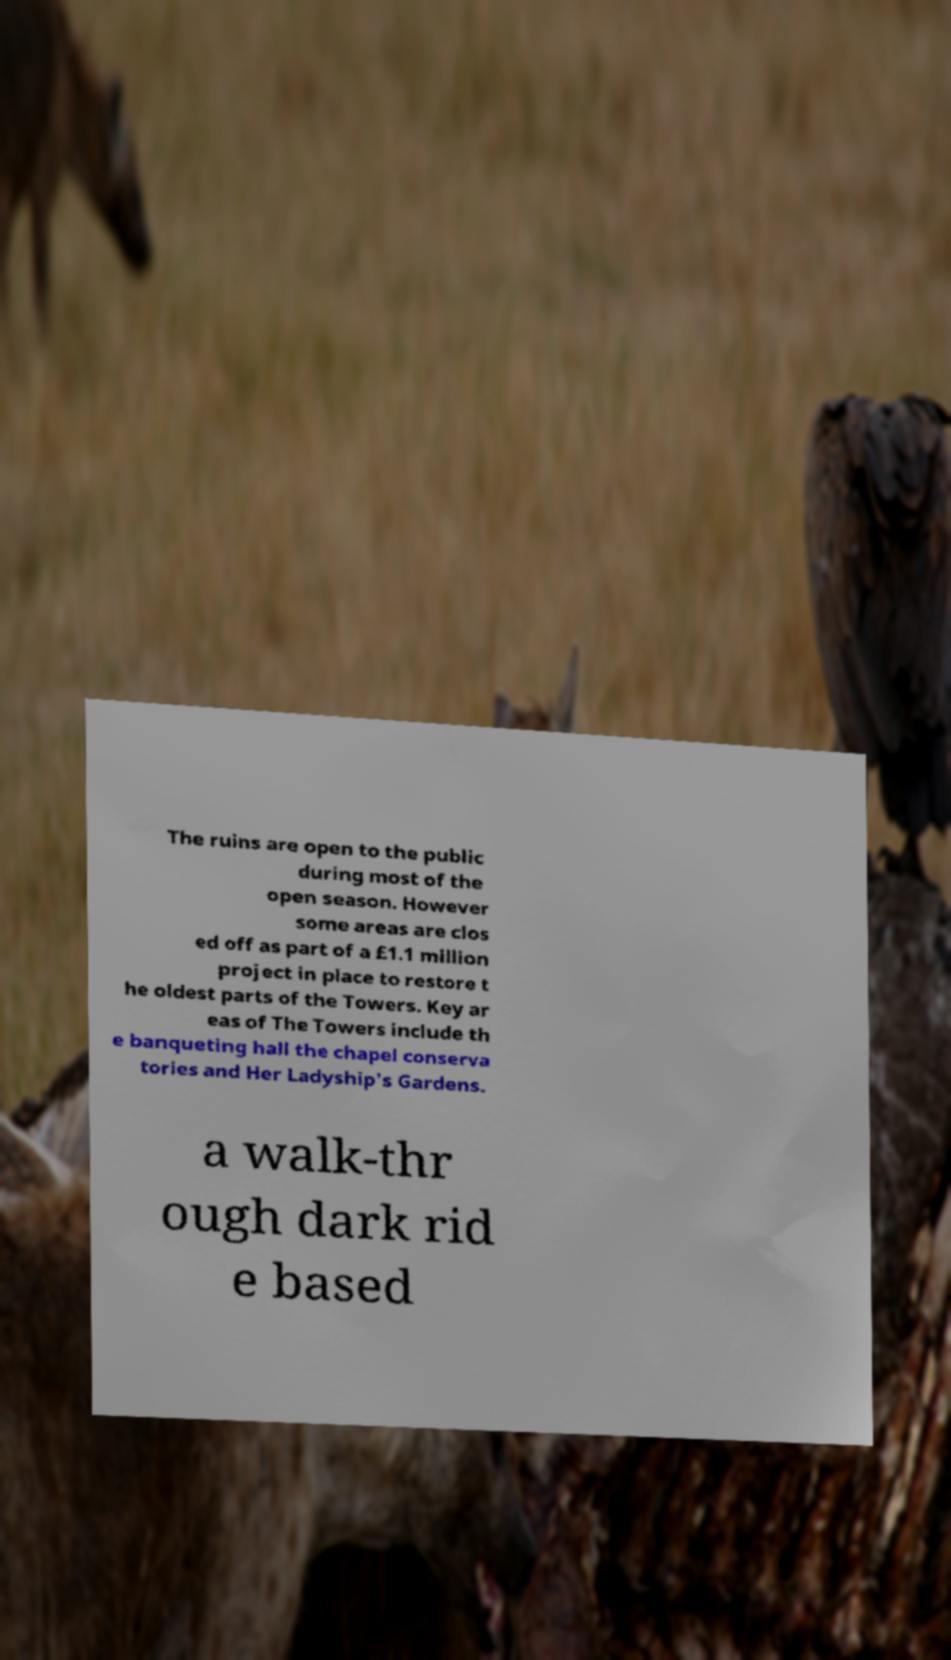Please read and relay the text visible in this image. What does it say? The ruins are open to the public during most of the open season. However some areas are clos ed off as part of a £1.1 million project in place to restore t he oldest parts of the Towers. Key ar eas of The Towers include th e banqueting hall the chapel conserva tories and Her Ladyship's Gardens. a walk-thr ough dark rid e based 